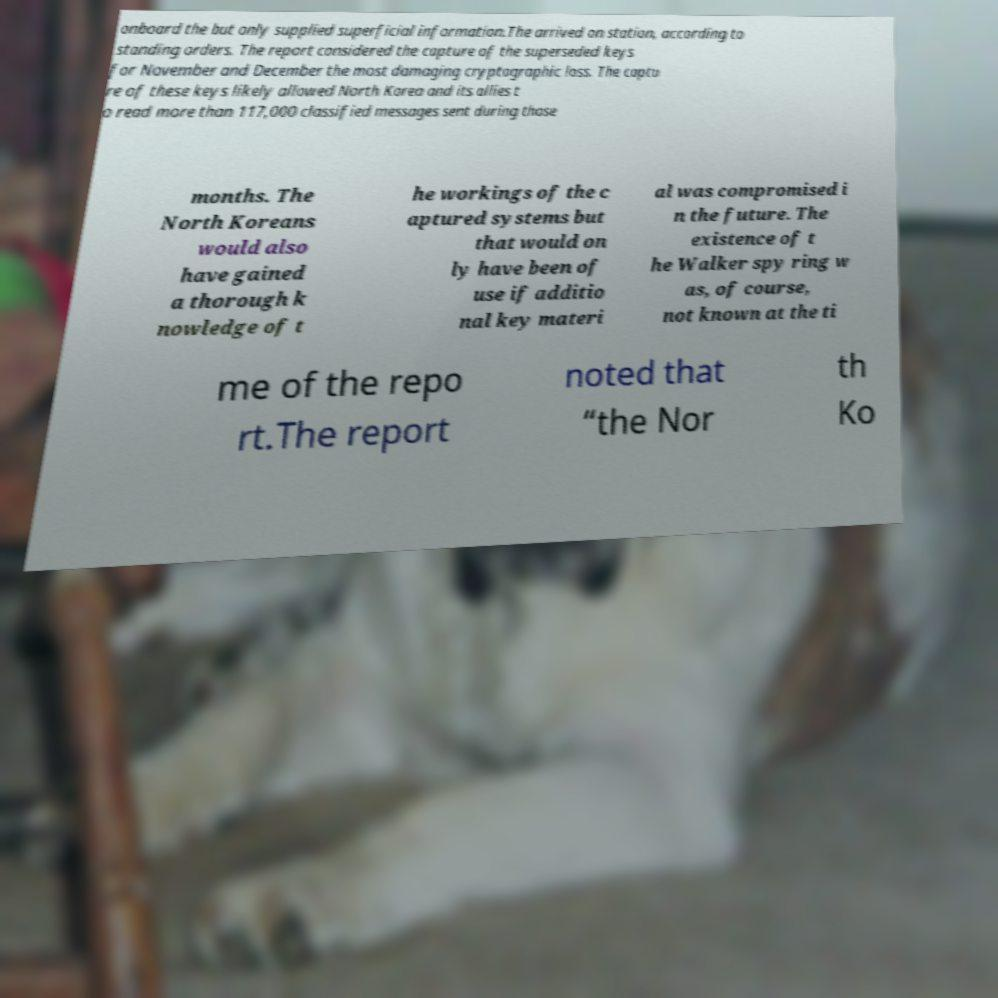Could you extract and type out the text from this image? onboard the but only supplied superficial information.The arrived on station, according to standing orders. The report considered the capture of the superseded keys for November and December the most damaging cryptographic loss. The captu re of these keys likely allowed North Korea and its allies t o read more than 117,000 classified messages sent during those months. The North Koreans would also have gained a thorough k nowledge of t he workings of the c aptured systems but that would on ly have been of use if additio nal key materi al was compromised i n the future. The existence of t he Walker spy ring w as, of course, not known at the ti me of the repo rt.The report noted that “the Nor th Ko 